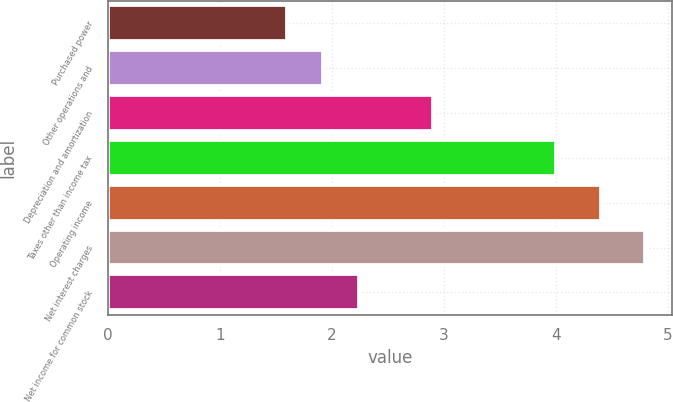Convert chart to OTSL. <chart><loc_0><loc_0><loc_500><loc_500><bar_chart><fcel>Purchased power<fcel>Other operations and<fcel>Depreciation and amortization<fcel>Taxes other than income tax<fcel>Operating income<fcel>Net interest charges<fcel>Net income for common stock<nl><fcel>1.6<fcel>1.92<fcel>2.9<fcel>4<fcel>4.4<fcel>4.8<fcel>2.24<nl></chart> 